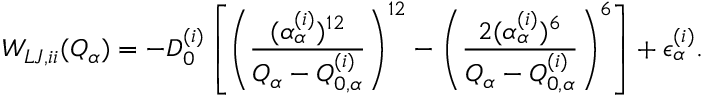Convert formula to latex. <formula><loc_0><loc_0><loc_500><loc_500>W _ { L J , i i } ( Q _ { \alpha } ) = - D _ { 0 } ^ { ( i ) } \left [ \left ( \frac { ( \alpha _ { \alpha } ^ { ( i ) } ) ^ { 1 2 } } { Q _ { \alpha } - Q _ { 0 , \alpha } ^ { ( i ) } } \right ) ^ { 1 2 } - \left ( \frac { 2 ( \alpha _ { \alpha } ^ { ( i ) } ) ^ { 6 } } { Q _ { \alpha } - Q _ { 0 , \alpha } ^ { ( i ) } } \right ) ^ { 6 } \right ] + \epsilon _ { \alpha } ^ { ( i ) } .</formula> 